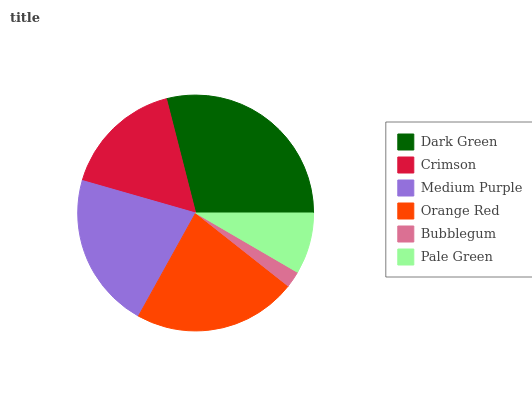Is Bubblegum the minimum?
Answer yes or no. Yes. Is Dark Green the maximum?
Answer yes or no. Yes. Is Crimson the minimum?
Answer yes or no. No. Is Crimson the maximum?
Answer yes or no. No. Is Dark Green greater than Crimson?
Answer yes or no. Yes. Is Crimson less than Dark Green?
Answer yes or no. Yes. Is Crimson greater than Dark Green?
Answer yes or no. No. Is Dark Green less than Crimson?
Answer yes or no. No. Is Medium Purple the high median?
Answer yes or no. Yes. Is Crimson the low median?
Answer yes or no. Yes. Is Orange Red the high median?
Answer yes or no. No. Is Orange Red the low median?
Answer yes or no. No. 